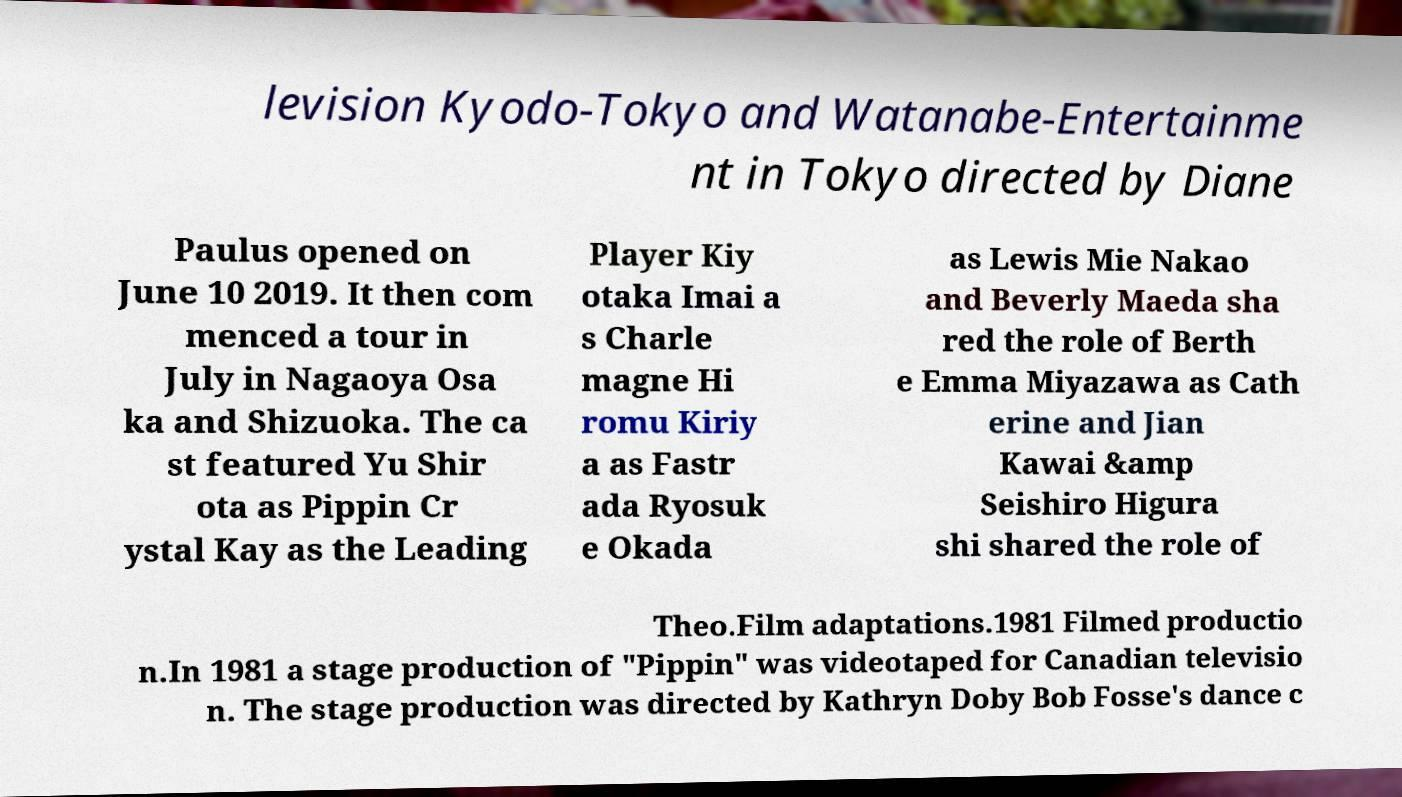Could you assist in decoding the text presented in this image and type it out clearly? levision Kyodo-Tokyo and Watanabe-Entertainme nt in Tokyo directed by Diane Paulus opened on June 10 2019. It then com menced a tour in July in Nagaoya Osa ka and Shizuoka. The ca st featured Yu Shir ota as Pippin Cr ystal Kay as the Leading Player Kiy otaka Imai a s Charle magne Hi romu Kiriy a as Fastr ada Ryosuk e Okada as Lewis Mie Nakao and Beverly Maeda sha red the role of Berth e Emma Miyazawa as Cath erine and Jian Kawai &amp Seishiro Higura shi shared the role of Theo.Film adaptations.1981 Filmed productio n.In 1981 a stage production of "Pippin" was videotaped for Canadian televisio n. The stage production was directed by Kathryn Doby Bob Fosse's dance c 